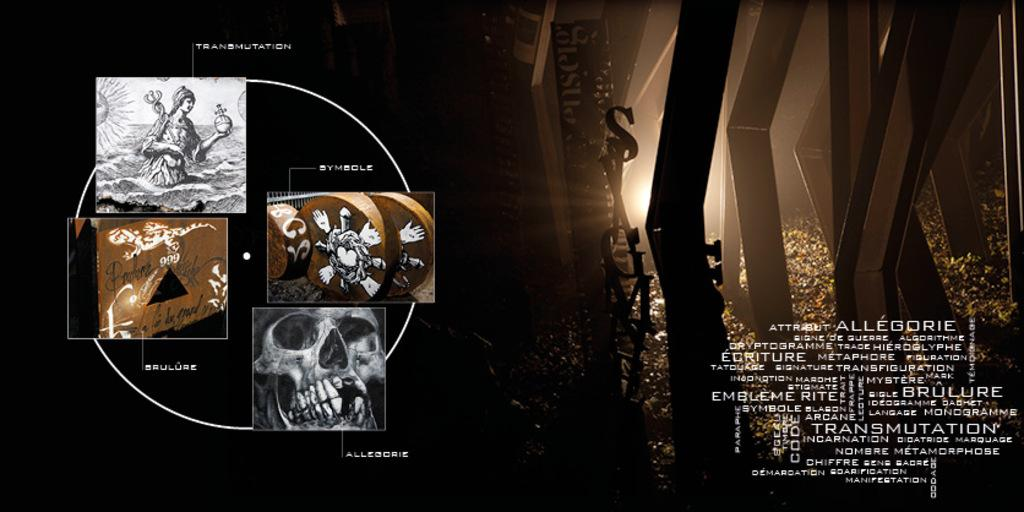Provide a one-sentence caption for the provided image. Symbols for Allegorie can be seen on a dark poster. 